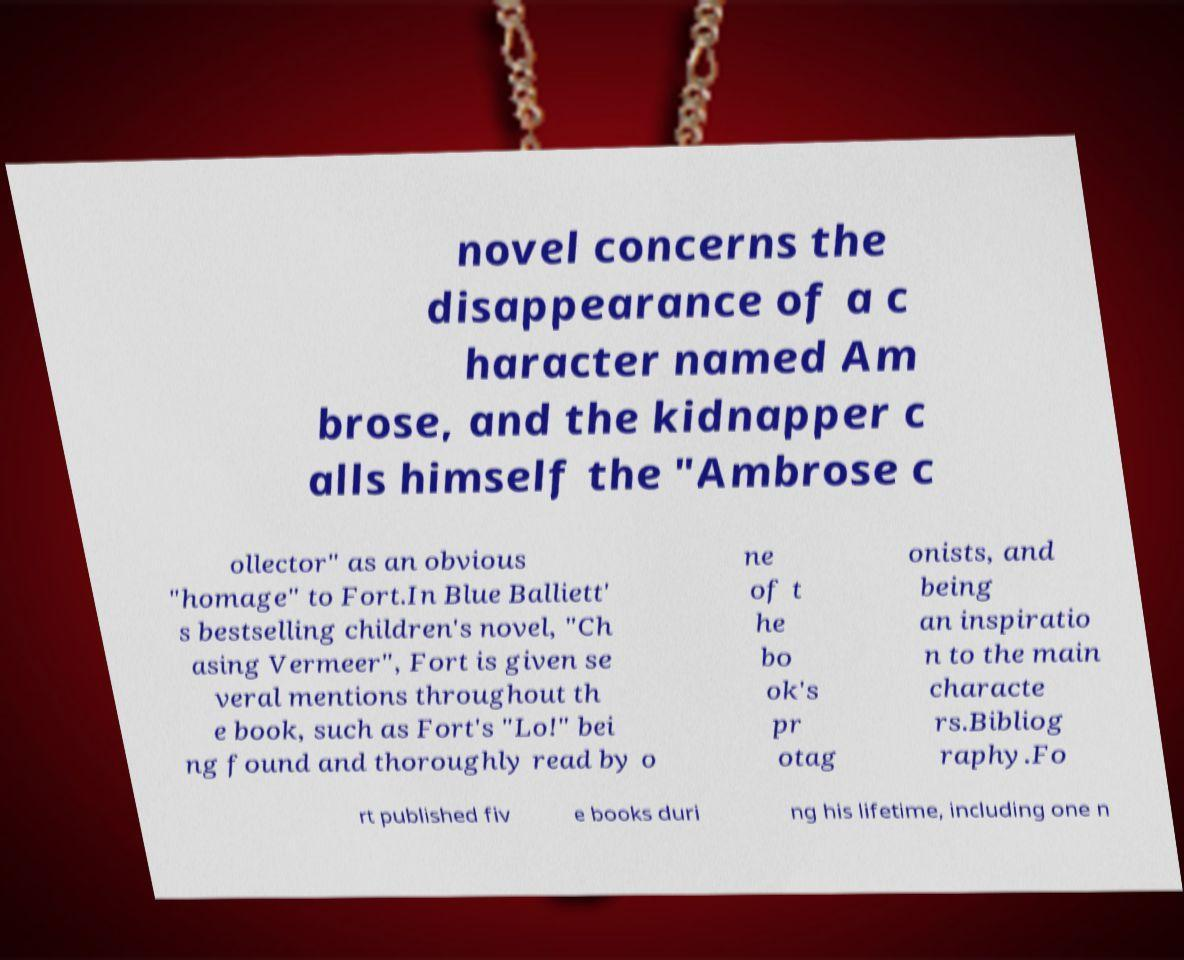What messages or text are displayed in this image? I need them in a readable, typed format. novel concerns the disappearance of a c haracter named Am brose, and the kidnapper c alls himself the "Ambrose c ollector" as an obvious "homage" to Fort.In Blue Balliett' s bestselling children's novel, "Ch asing Vermeer", Fort is given se veral mentions throughout th e book, such as Fort's "Lo!" bei ng found and thoroughly read by o ne of t he bo ok's pr otag onists, and being an inspiratio n to the main characte rs.Bibliog raphy.Fo rt published fiv e books duri ng his lifetime, including one n 